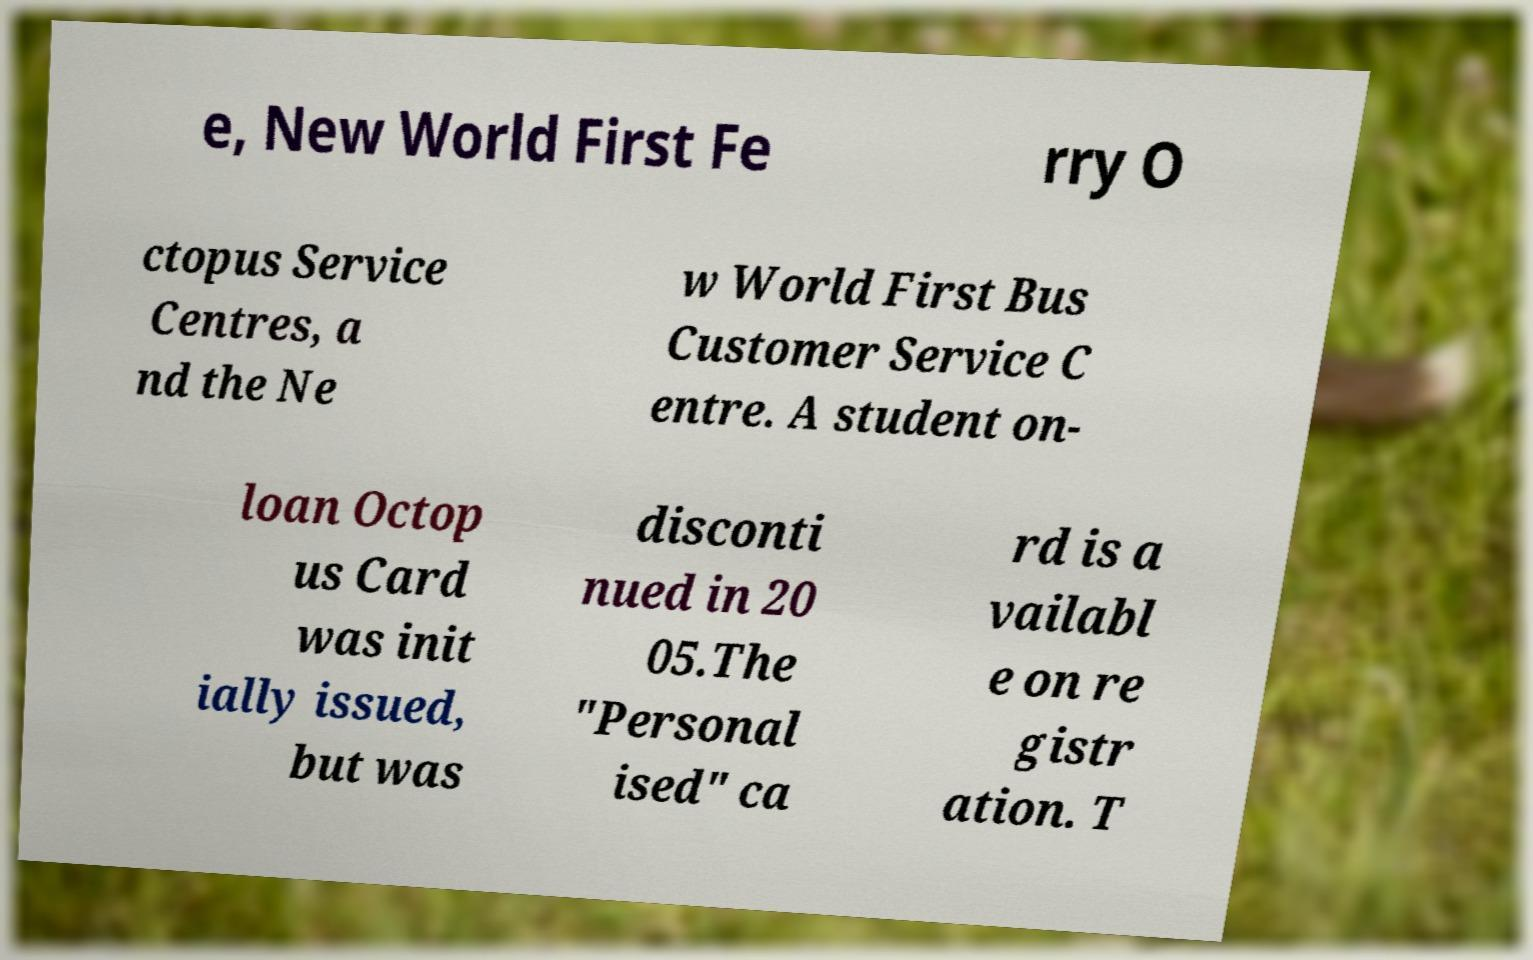For documentation purposes, I need the text within this image transcribed. Could you provide that? e, New World First Fe rry O ctopus Service Centres, a nd the Ne w World First Bus Customer Service C entre. A student on- loan Octop us Card was init ially issued, but was disconti nued in 20 05.The "Personal ised" ca rd is a vailabl e on re gistr ation. T 